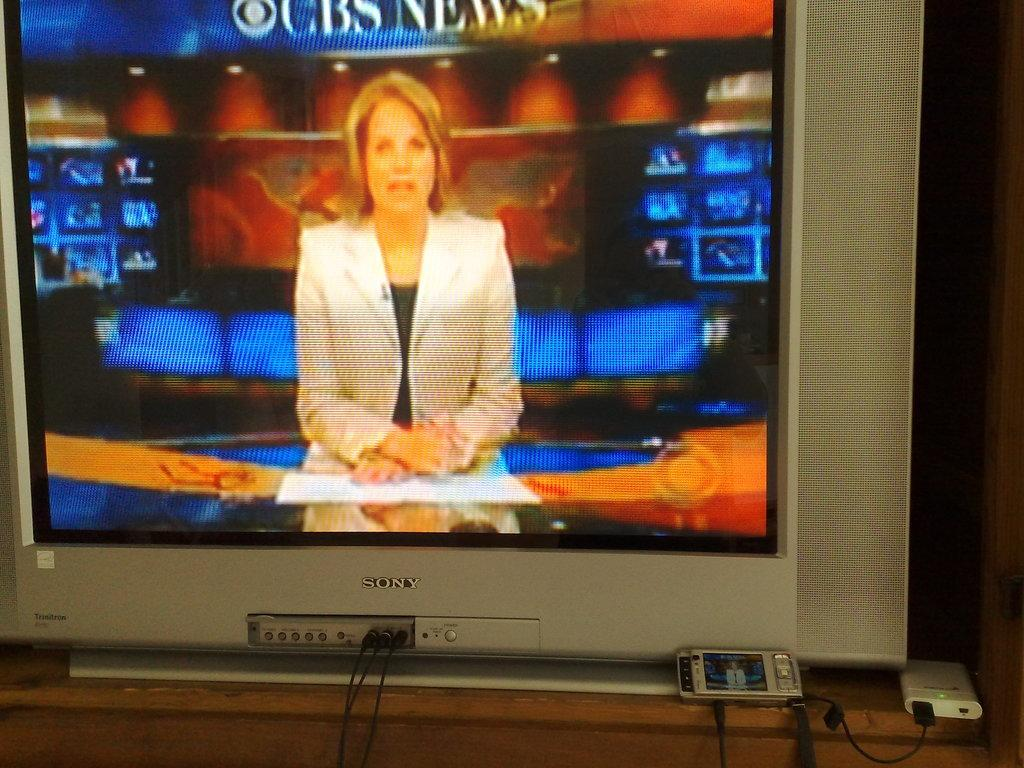Provide a one-sentence caption for the provided image. Sony Television Screen that has on CBS News with I think Katie Couric. 